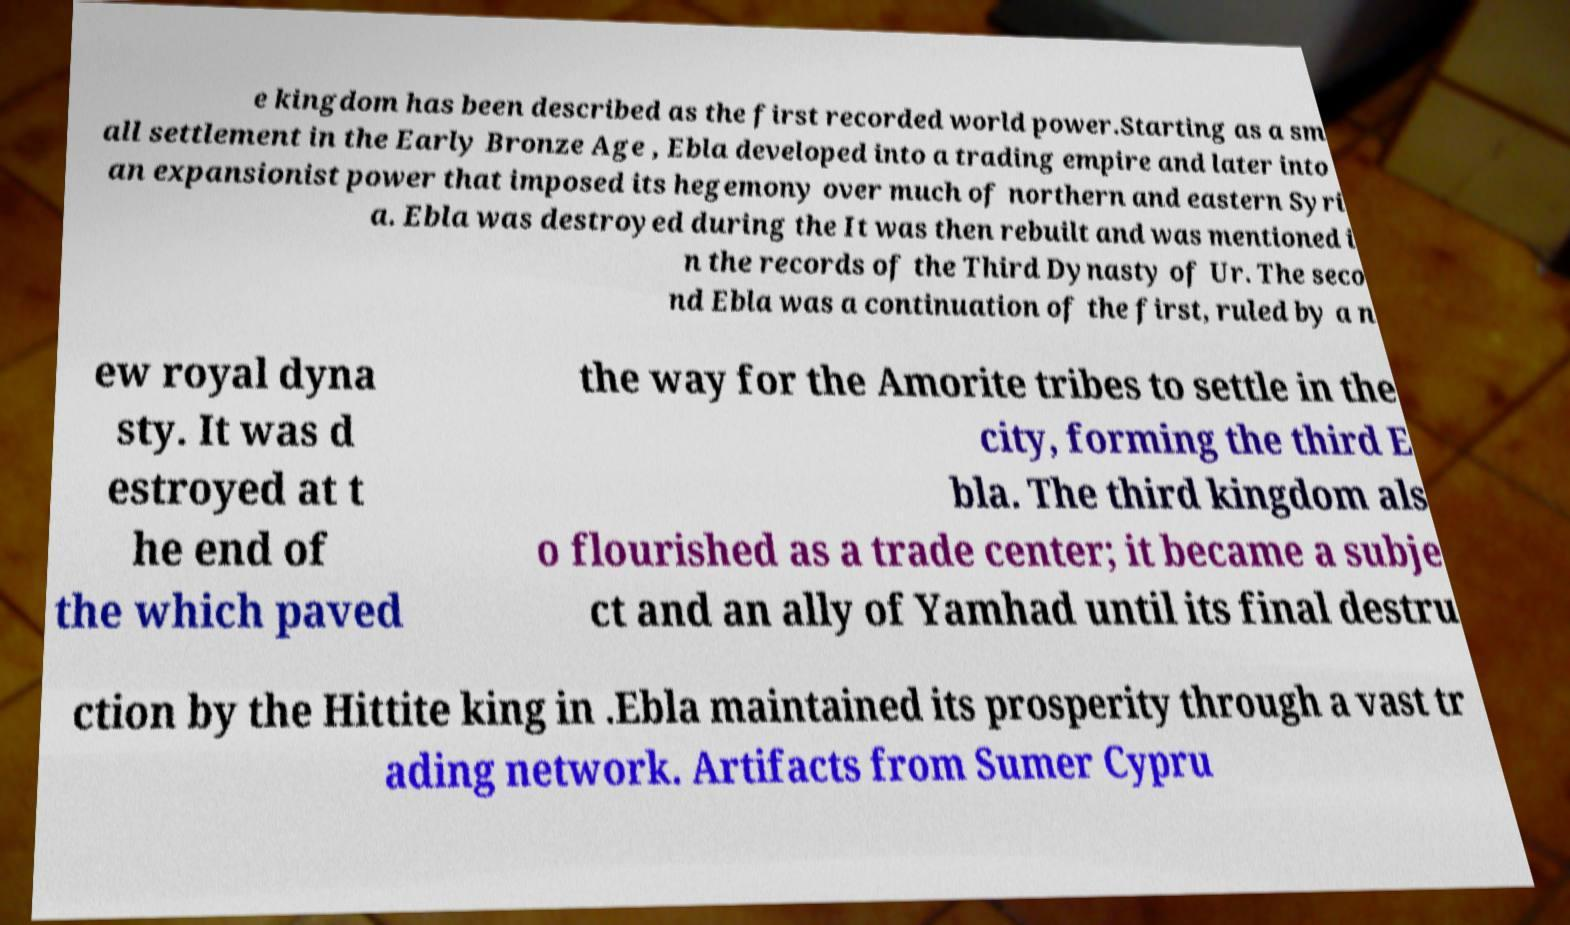For documentation purposes, I need the text within this image transcribed. Could you provide that? e kingdom has been described as the first recorded world power.Starting as a sm all settlement in the Early Bronze Age , Ebla developed into a trading empire and later into an expansionist power that imposed its hegemony over much of northern and eastern Syri a. Ebla was destroyed during the It was then rebuilt and was mentioned i n the records of the Third Dynasty of Ur. The seco nd Ebla was a continuation of the first, ruled by a n ew royal dyna sty. It was d estroyed at t he end of the which paved the way for the Amorite tribes to settle in the city, forming the third E bla. The third kingdom als o flourished as a trade center; it became a subje ct and an ally of Yamhad until its final destru ction by the Hittite king in .Ebla maintained its prosperity through a vast tr ading network. Artifacts from Sumer Cypru 